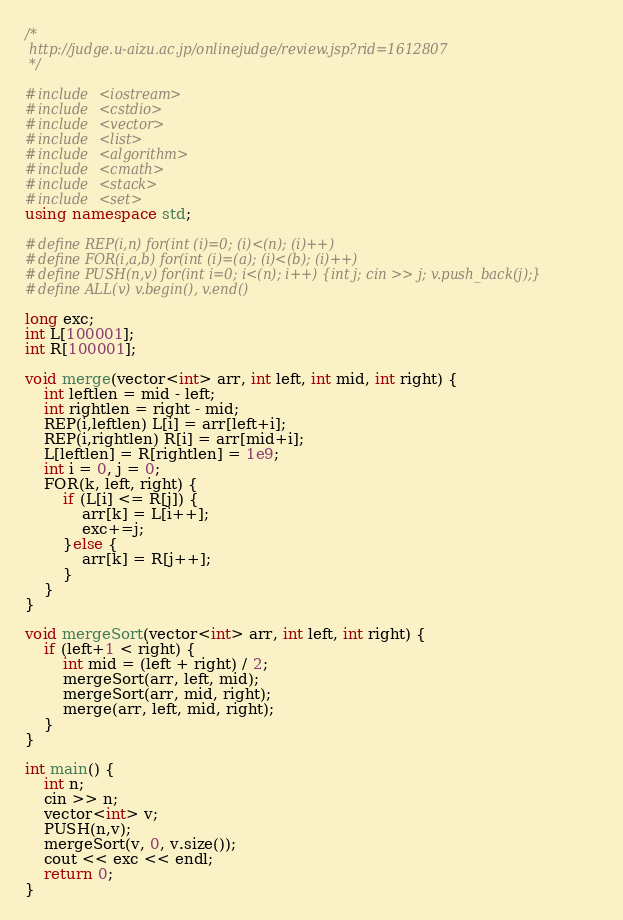Convert code to text. <code><loc_0><loc_0><loc_500><loc_500><_C++_>/*
 http://judge.u-aizu.ac.jp/onlinejudge/review.jsp?rid=1612807
 */

#include <iostream>
#include <cstdio>
#include <vector>
#include <list>
#include <algorithm>
#include <cmath>
#include <stack>
#include <set>
using namespace std;

#define REP(i,n) for(int (i)=0; (i)<(n); (i)++)
#define FOR(i,a,b) for(int (i)=(a); (i)<(b); (i)++)
#define PUSH(n,v) for(int i=0; i<(n); i++) {int j; cin >> j; v.push_back(j);}
#define ALL(v) v.begin(), v.end()

long exc;
int L[100001];
int R[100001];

void merge(vector<int> arr, int left, int mid, int right) {
    int leftlen = mid - left;
    int rightlen = right - mid;
    REP(i,leftlen) L[i] = arr[left+i];
    REP(i,rightlen) R[i] = arr[mid+i];
    L[leftlen] = R[rightlen] = 1e9;
    int i = 0, j = 0;
    FOR(k, left, right) {
        if (L[i] <= R[j]) {
            arr[k] = L[i++];
            exc+=j;
        }else {
            arr[k] = R[j++];
        }
    }
}

void mergeSort(vector<int> arr, int left, int right) {
    if (left+1 < right) {
        int mid = (left + right) / 2;
        mergeSort(arr, left, mid);
        mergeSort(arr, mid, right);
        merge(arr, left, mid, right);
    }
}

int main() {
    int n;
    cin >> n;
    vector<int> v;
    PUSH(n,v);
    mergeSort(v, 0, v.size());
    cout << exc << endl;
    return 0;
}</code> 